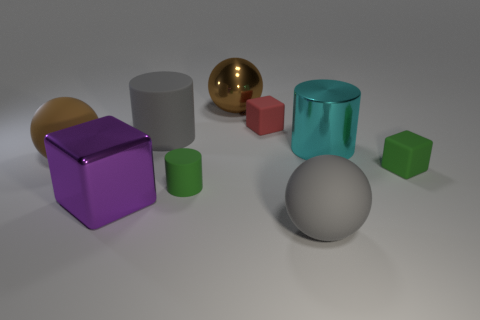Subtract 1 cylinders. How many cylinders are left? 2 Subtract all cylinders. How many objects are left? 6 Add 6 big shiny cubes. How many big shiny cubes are left? 7 Add 3 small green blocks. How many small green blocks exist? 4 Subtract 0 cyan spheres. How many objects are left? 9 Subtract all big yellow metallic objects. Subtract all small red things. How many objects are left? 8 